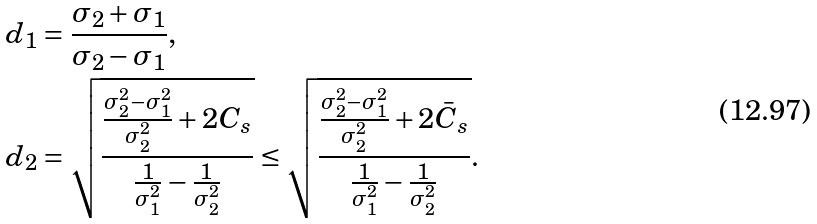Convert formula to latex. <formula><loc_0><loc_0><loc_500><loc_500>d _ { 1 } & = \frac { \sigma _ { 2 } + \sigma _ { 1 } } { \sigma _ { 2 } - \sigma _ { 1 } } , \\ d _ { 2 } & = \sqrt { \frac { \frac { \sigma _ { 2 } ^ { 2 } - \sigma _ { 1 } ^ { 2 } } { \sigma _ { 2 } ^ { 2 } } + 2 C _ { s } } { \frac { 1 } { \sigma _ { 1 } ^ { 2 } } - \frac { 1 } { \sigma _ { 2 } ^ { 2 } } } } \leq \sqrt { \frac { \frac { \sigma _ { 2 } ^ { 2 } - \sigma _ { 1 } ^ { 2 } } { \sigma _ { 2 } ^ { 2 } } + 2 \bar { C } _ { s } } { \frac { 1 } { \sigma _ { 1 } ^ { 2 } } - \frac { 1 } { \sigma _ { 2 } ^ { 2 } } } } .</formula> 